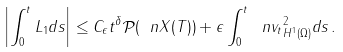<formula> <loc_0><loc_0><loc_500><loc_500>\left | \int _ { 0 } ^ { t } L _ { 1 } d s \right | \leq C _ { \epsilon } t ^ { \delta } { \mathcal { P } } ( \ n X ( T ) ) + \epsilon \int _ { 0 } ^ { t } \| \ n v _ { t } \| ^ { 2 } _ { H ^ { 1 } ( \Omega ) } d s \, .</formula> 